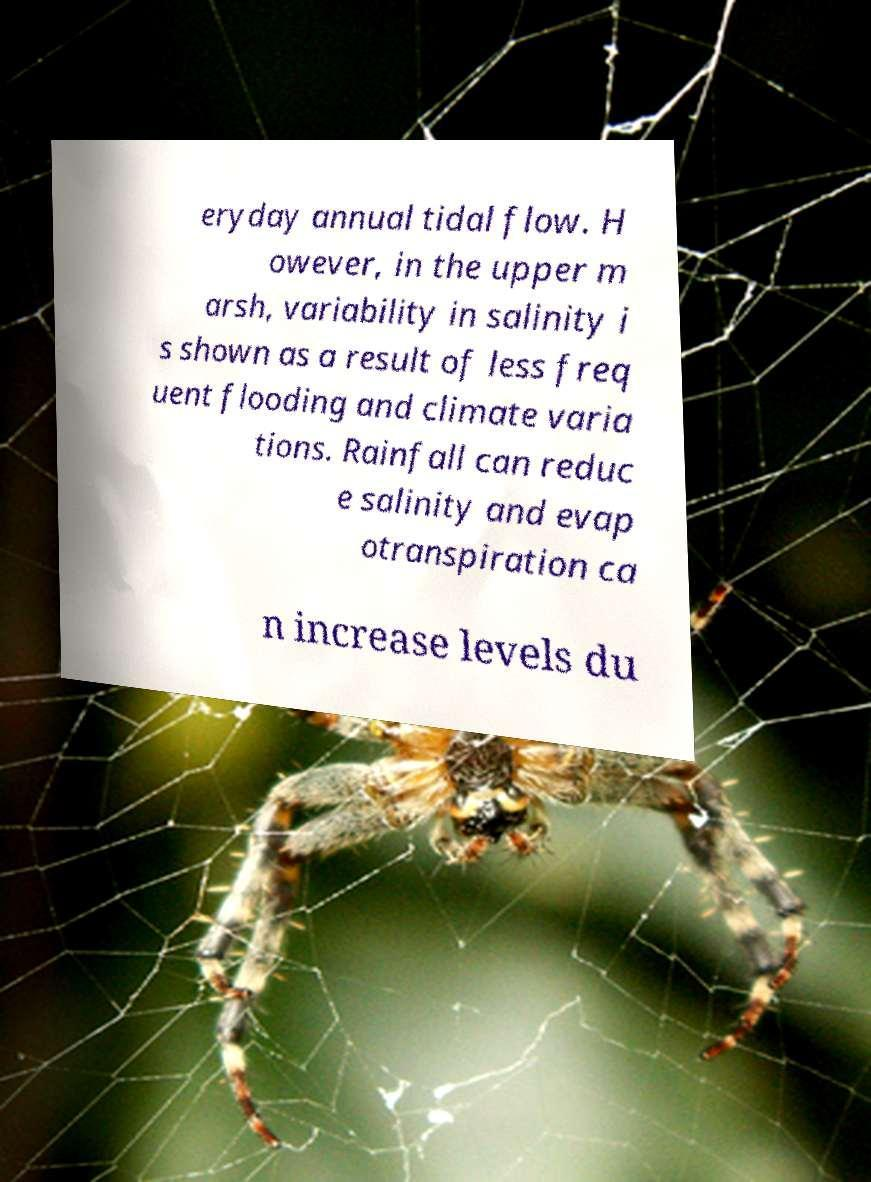For documentation purposes, I need the text within this image transcribed. Could you provide that? eryday annual tidal flow. H owever, in the upper m arsh, variability in salinity i s shown as a result of less freq uent flooding and climate varia tions. Rainfall can reduc e salinity and evap otranspiration ca n increase levels du 